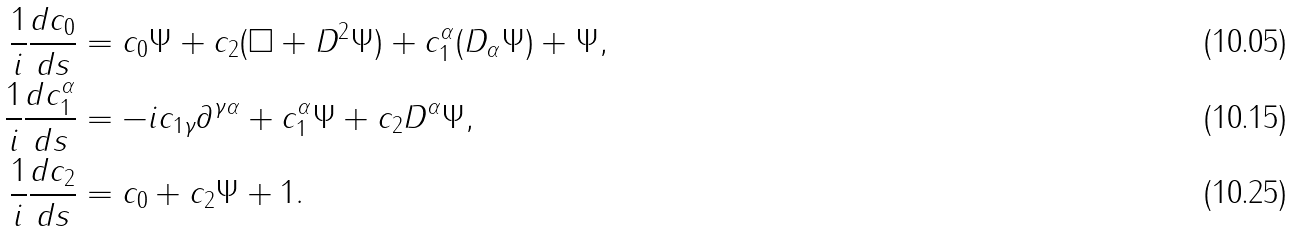<formula> <loc_0><loc_0><loc_500><loc_500>\frac { 1 } { i } \frac { d c _ { 0 } } { d s } & = c _ { 0 } \Psi + c _ { 2 } ( \Box + D ^ { 2 } \Psi ) + c _ { 1 } ^ { \alpha } ( D _ { \alpha } \Psi ) + \Psi , \\ \frac { 1 } { i } \frac { d c _ { 1 } ^ { \alpha } } { d s } & = - i c _ { 1 \gamma } \partial ^ { \gamma \alpha } + c _ { 1 } ^ { \alpha } \Psi + c _ { 2 } D ^ { \alpha } \Psi , \\ \frac { 1 } { i } \frac { d c _ { 2 } } { d s } & = c _ { 0 } + c _ { 2 } \Psi + 1 .</formula> 